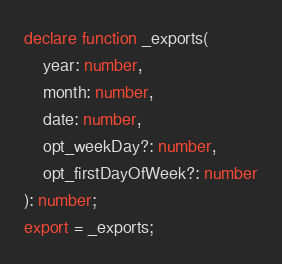<code> <loc_0><loc_0><loc_500><loc_500><_TypeScript_>declare function _exports(
    year: number,
    month: number,
    date: number,
    opt_weekDay?: number,
    opt_firstDayOfWeek?: number
): number;
export = _exports;
</code> 